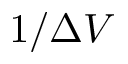<formula> <loc_0><loc_0><loc_500><loc_500>1 / \Delta V</formula> 